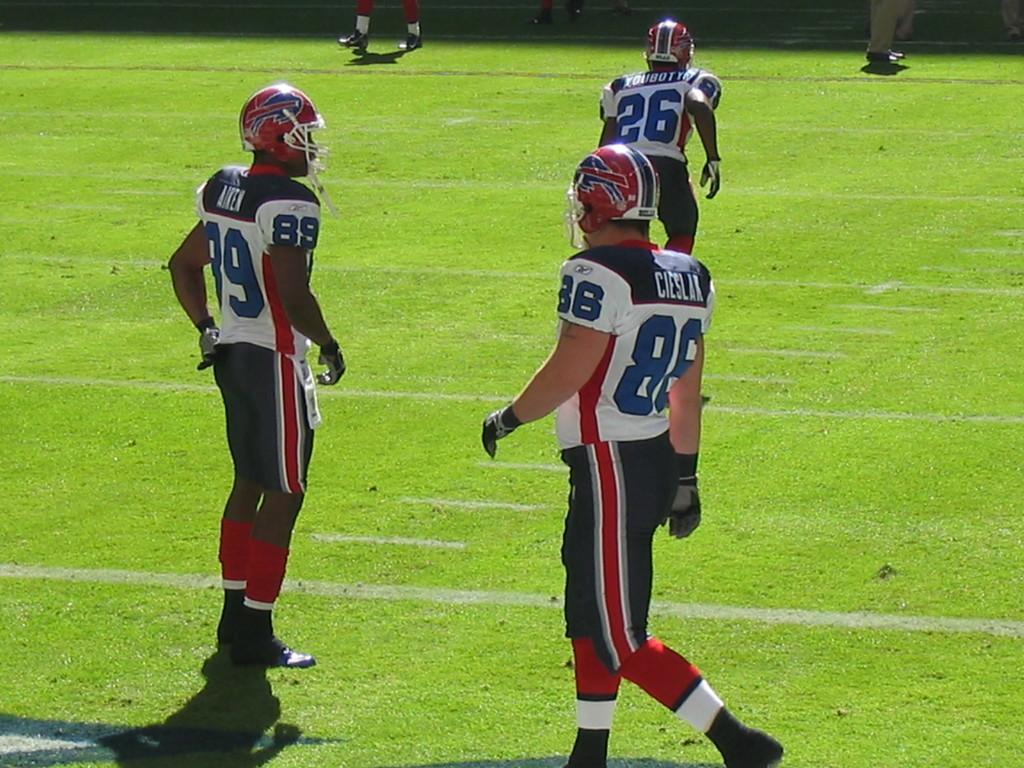How would you summarize this image in a sentence or two? In this image I can see the group of people standing on the ground. I can see these people are wearing the jerseys and helmets. 